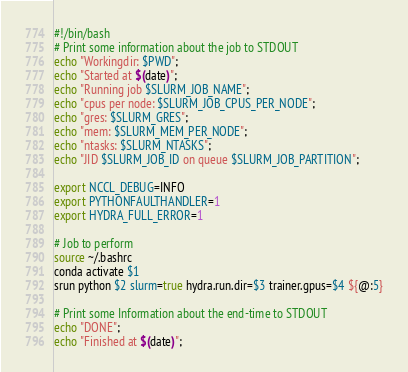Convert code to text. <code><loc_0><loc_0><loc_500><loc_500><_Bash_>#!/bin/bash
# Print some information about the job to STDOUT
echo "Workingdir: $PWD";
echo "Started at $(date)";
echo "Running job $SLURM_JOB_NAME";
echo "cpus per node: $SLURM_JOB_CPUS_PER_NODE";
echo "gres: $SLURM_GRES";
echo "mem: $SLURM_MEM_PER_NODE";
echo "ntasks: $SLURM_NTASKS";
echo "JID $SLURM_JOB_ID on queue $SLURM_JOB_PARTITION";

export NCCL_DEBUG=INFO
export PYTHONFAULTHANDLER=1
export HYDRA_FULL_ERROR=1

# Job to perform
source ~/.bashrc
conda activate $1
srun python $2 slurm=true hydra.run.dir=$3 trainer.gpus=$4 ${@:5}

# Print some Information about the end-time to STDOUT
echo "DONE";
echo "Finished at $(date)";
</code> 